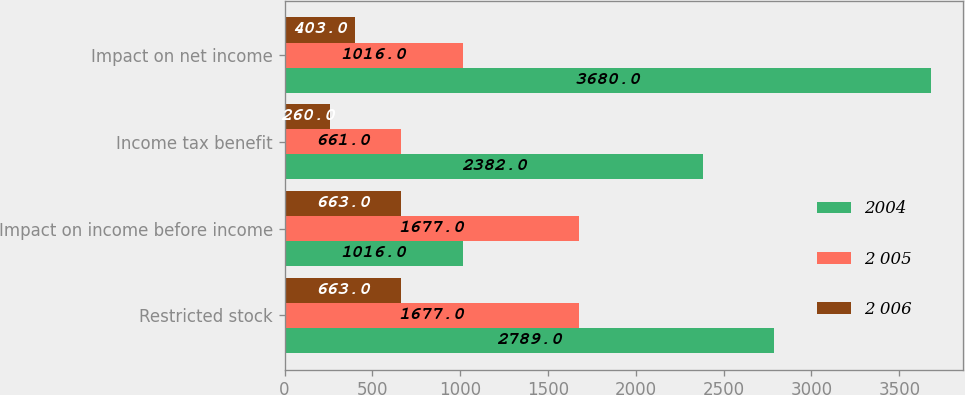<chart> <loc_0><loc_0><loc_500><loc_500><stacked_bar_chart><ecel><fcel>Restricted stock<fcel>Impact on income before income<fcel>Income tax benefit<fcel>Impact on net income<nl><fcel>2004<fcel>2789<fcel>1016<fcel>2382<fcel>3680<nl><fcel>2 005<fcel>1677<fcel>1677<fcel>661<fcel>1016<nl><fcel>2 006<fcel>663<fcel>663<fcel>260<fcel>403<nl></chart> 